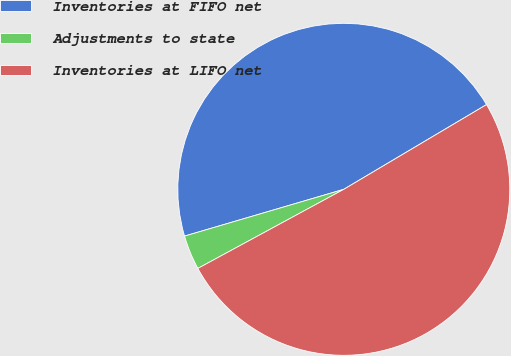Convert chart to OTSL. <chart><loc_0><loc_0><loc_500><loc_500><pie_chart><fcel>Inventories at FIFO net<fcel>Adjustments to state<fcel>Inventories at LIFO net<nl><fcel>46.02%<fcel>3.36%<fcel>50.62%<nl></chart> 